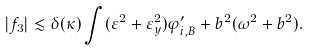<formula> <loc_0><loc_0><loc_500><loc_500>| f _ { 3 } | \lesssim \delta ( \kappa ) \int ( \varepsilon ^ { 2 } + \varepsilon _ { y } ^ { 2 } ) \varphi _ { i , B } ^ { \prime } + b ^ { 2 } ( \omega ^ { 2 } + b ^ { 2 } ) .</formula> 